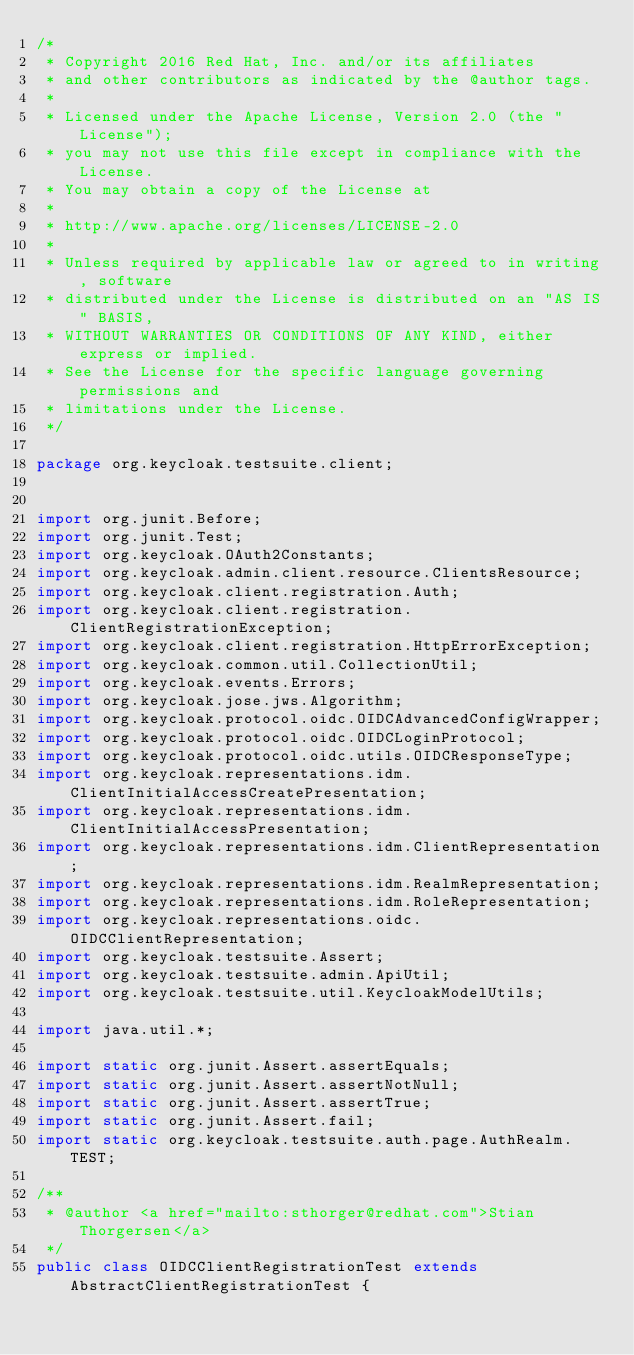<code> <loc_0><loc_0><loc_500><loc_500><_Java_>/*
 * Copyright 2016 Red Hat, Inc. and/or its affiliates
 * and other contributors as indicated by the @author tags.
 *
 * Licensed under the Apache License, Version 2.0 (the "License");
 * you may not use this file except in compliance with the License.
 * You may obtain a copy of the License at
 *
 * http://www.apache.org/licenses/LICENSE-2.0
 *
 * Unless required by applicable law or agreed to in writing, software
 * distributed under the License is distributed on an "AS IS" BASIS,
 * WITHOUT WARRANTIES OR CONDITIONS OF ANY KIND, either express or implied.
 * See the License for the specific language governing permissions and
 * limitations under the License.
 */

package org.keycloak.testsuite.client;


import org.junit.Before;
import org.junit.Test;
import org.keycloak.OAuth2Constants;
import org.keycloak.admin.client.resource.ClientsResource;
import org.keycloak.client.registration.Auth;
import org.keycloak.client.registration.ClientRegistrationException;
import org.keycloak.client.registration.HttpErrorException;
import org.keycloak.common.util.CollectionUtil;
import org.keycloak.events.Errors;
import org.keycloak.jose.jws.Algorithm;
import org.keycloak.protocol.oidc.OIDCAdvancedConfigWrapper;
import org.keycloak.protocol.oidc.OIDCLoginProtocol;
import org.keycloak.protocol.oidc.utils.OIDCResponseType;
import org.keycloak.representations.idm.ClientInitialAccessCreatePresentation;
import org.keycloak.representations.idm.ClientInitialAccessPresentation;
import org.keycloak.representations.idm.ClientRepresentation;
import org.keycloak.representations.idm.RealmRepresentation;
import org.keycloak.representations.idm.RoleRepresentation;
import org.keycloak.representations.oidc.OIDCClientRepresentation;
import org.keycloak.testsuite.Assert;
import org.keycloak.testsuite.admin.ApiUtil;
import org.keycloak.testsuite.util.KeycloakModelUtils;

import java.util.*;

import static org.junit.Assert.assertEquals;
import static org.junit.Assert.assertNotNull;
import static org.junit.Assert.assertTrue;
import static org.junit.Assert.fail;
import static org.keycloak.testsuite.auth.page.AuthRealm.TEST;

/**
 * @author <a href="mailto:sthorger@redhat.com">Stian Thorgersen</a>
 */
public class OIDCClientRegistrationTest extends AbstractClientRegistrationTest {
</code> 